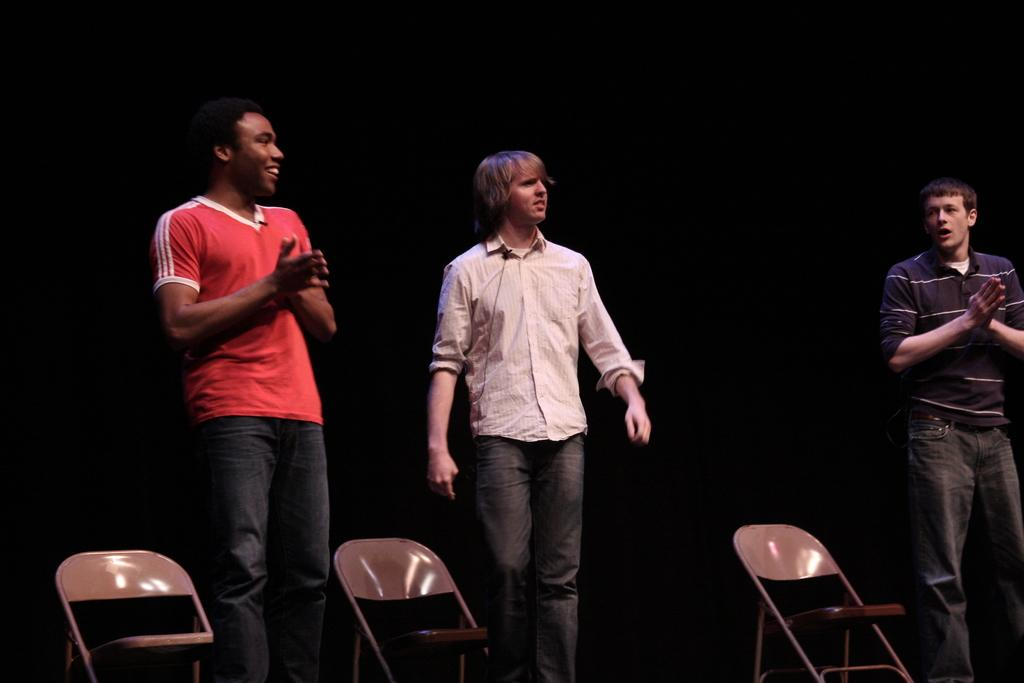How many people are in the image? There are three persons standing in the image. What is located at the bottom of the image? Chairs are visible at the bottom of the image. How would you describe the background of the image? The background of the image has a dark view. Are the three persons in the image sisters? There is no information provided about the relationship between the three persons in the image, so we cannot determine if they are sisters. Can you see a guitar in the image? There is no guitar present in the image. 